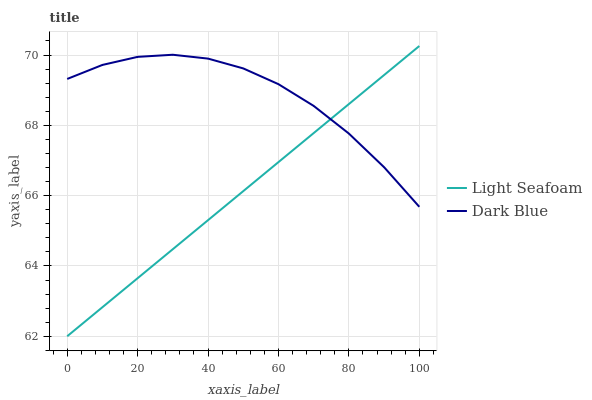Does Light Seafoam have the minimum area under the curve?
Answer yes or no. Yes. Does Dark Blue have the maximum area under the curve?
Answer yes or no. Yes. Does Light Seafoam have the maximum area under the curve?
Answer yes or no. No. Is Light Seafoam the smoothest?
Answer yes or no. Yes. Is Dark Blue the roughest?
Answer yes or no. Yes. Is Light Seafoam the roughest?
Answer yes or no. No. Does Light Seafoam have the lowest value?
Answer yes or no. Yes. Does Light Seafoam have the highest value?
Answer yes or no. Yes. Does Dark Blue intersect Light Seafoam?
Answer yes or no. Yes. Is Dark Blue less than Light Seafoam?
Answer yes or no. No. Is Dark Blue greater than Light Seafoam?
Answer yes or no. No. 